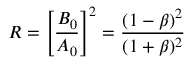<formula> <loc_0><loc_0><loc_500><loc_500>R = \left [ \frac { B _ { 0 } } { A _ { 0 } } \right ] ^ { 2 } = \frac { ( 1 - \beta ) ^ { 2 } } { ( 1 + \beta ) ^ { 2 } }</formula> 